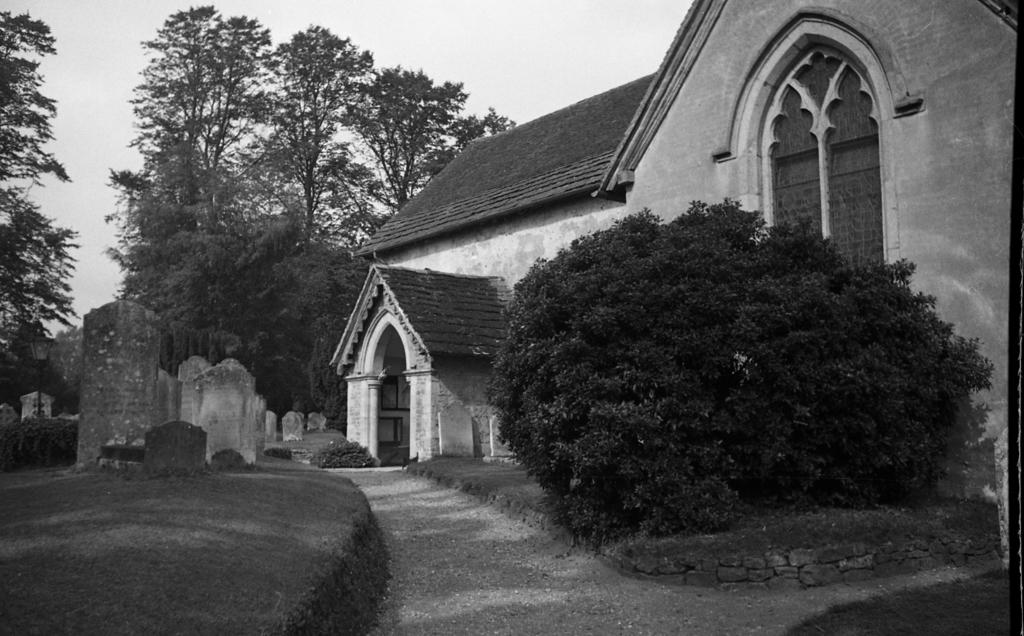What type of plant is visible in the image? There is a plant in the image, but its specific type cannot be determined from the provided facts. What structure is located in the image? There is a house in the image. What can be seen to the left of the image? There is a cemetery to the left of the image. What type of vegetation is visible in the background of the image? There are many trees in the background of the image. What is visible in the background of the image? The sky is visible in the background of the image. What is the color scheme of the image? The image is in black and white. How many people are participating in the feast in the image? There is no feast present in the image. What is the hand doing in the image? There is no hand visible in the image. What type of wave is depicted in the image? There is no wave present in the image. 